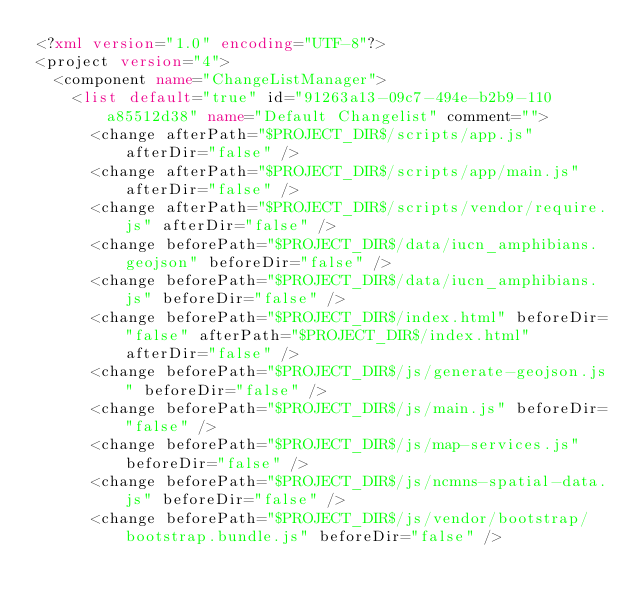<code> <loc_0><loc_0><loc_500><loc_500><_XML_><?xml version="1.0" encoding="UTF-8"?>
<project version="4">
  <component name="ChangeListManager">
    <list default="true" id="91263a13-09c7-494e-b2b9-110a85512d38" name="Default Changelist" comment="">
      <change afterPath="$PROJECT_DIR$/scripts/app.js" afterDir="false" />
      <change afterPath="$PROJECT_DIR$/scripts/app/main.js" afterDir="false" />
      <change afterPath="$PROJECT_DIR$/scripts/vendor/require.js" afterDir="false" />
      <change beforePath="$PROJECT_DIR$/data/iucn_amphibians.geojson" beforeDir="false" />
      <change beforePath="$PROJECT_DIR$/data/iucn_amphibians.js" beforeDir="false" />
      <change beforePath="$PROJECT_DIR$/index.html" beforeDir="false" afterPath="$PROJECT_DIR$/index.html" afterDir="false" />
      <change beforePath="$PROJECT_DIR$/js/generate-geojson.js" beforeDir="false" />
      <change beforePath="$PROJECT_DIR$/js/main.js" beforeDir="false" />
      <change beforePath="$PROJECT_DIR$/js/map-services.js" beforeDir="false" />
      <change beforePath="$PROJECT_DIR$/js/ncmns-spatial-data.js" beforeDir="false" />
      <change beforePath="$PROJECT_DIR$/js/vendor/bootstrap/bootstrap.bundle.js" beforeDir="false" /></code> 